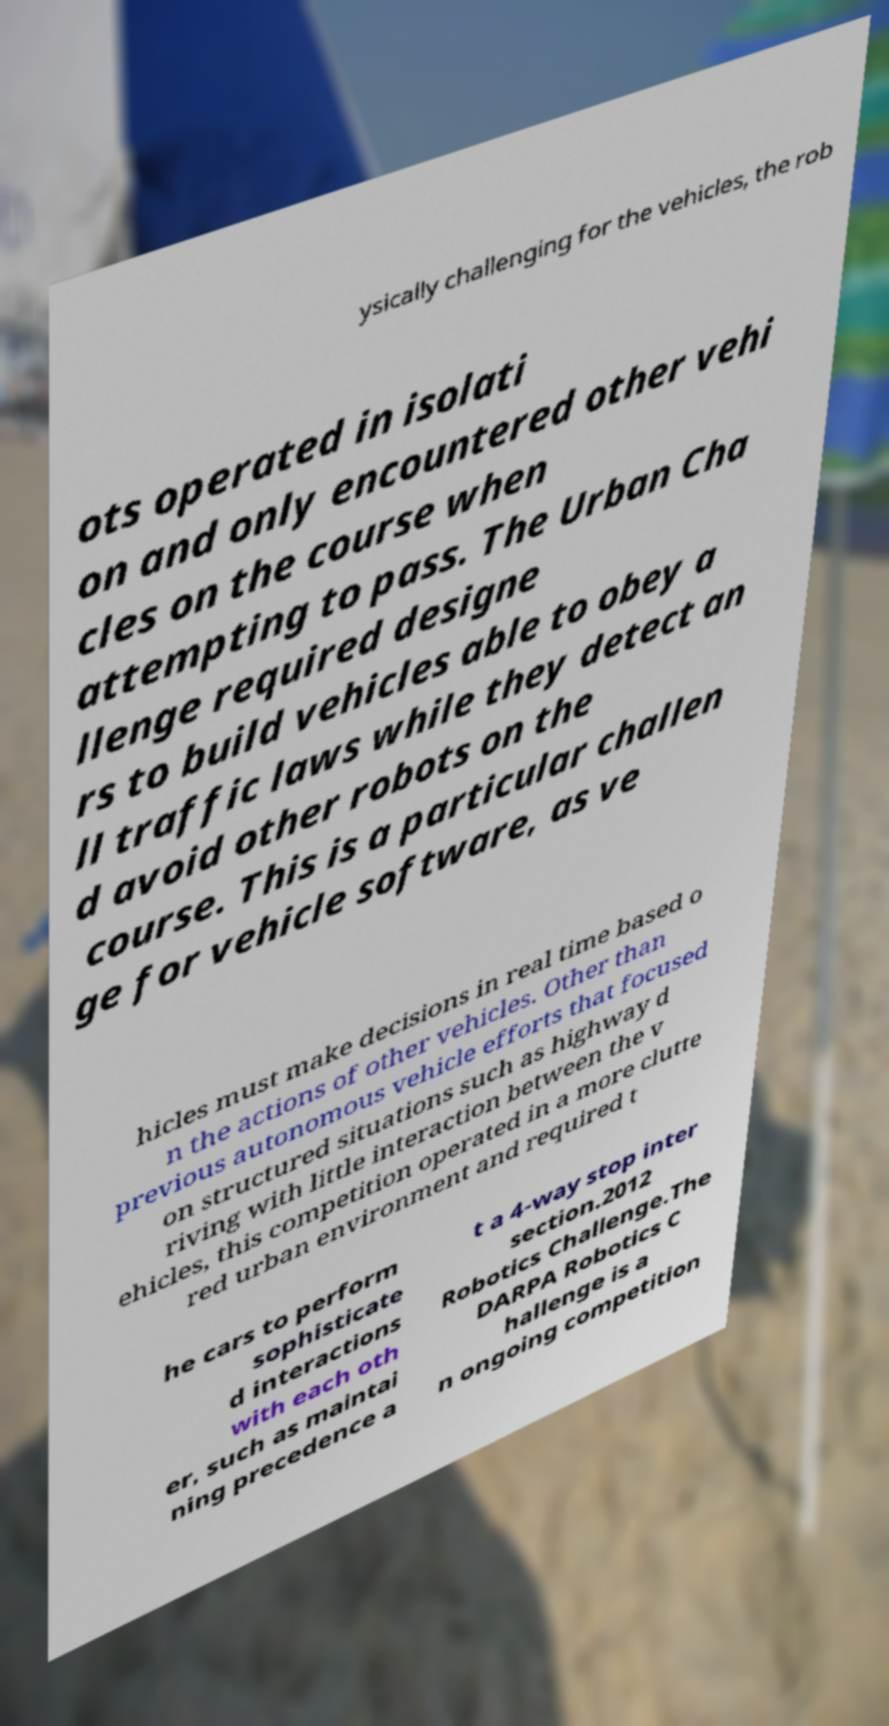Can you accurately transcribe the text from the provided image for me? ysically challenging for the vehicles, the rob ots operated in isolati on and only encountered other vehi cles on the course when attempting to pass. The Urban Cha llenge required designe rs to build vehicles able to obey a ll traffic laws while they detect an d avoid other robots on the course. This is a particular challen ge for vehicle software, as ve hicles must make decisions in real time based o n the actions of other vehicles. Other than previous autonomous vehicle efforts that focused on structured situations such as highway d riving with little interaction between the v ehicles, this competition operated in a more clutte red urban environment and required t he cars to perform sophisticate d interactions with each oth er, such as maintai ning precedence a t a 4-way stop inter section.2012 Robotics Challenge.The DARPA Robotics C hallenge is a n ongoing competition 